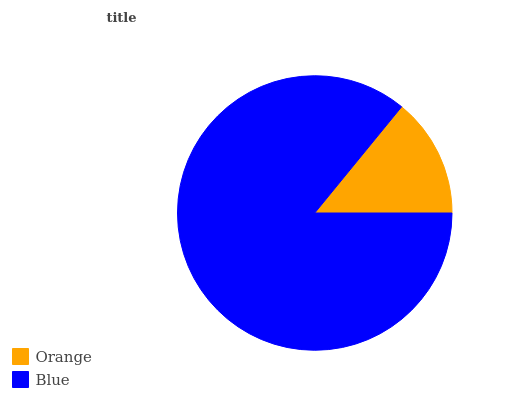Is Orange the minimum?
Answer yes or no. Yes. Is Blue the maximum?
Answer yes or no. Yes. Is Blue the minimum?
Answer yes or no. No. Is Blue greater than Orange?
Answer yes or no. Yes. Is Orange less than Blue?
Answer yes or no. Yes. Is Orange greater than Blue?
Answer yes or no. No. Is Blue less than Orange?
Answer yes or no. No. Is Blue the high median?
Answer yes or no. Yes. Is Orange the low median?
Answer yes or no. Yes. Is Orange the high median?
Answer yes or no. No. Is Blue the low median?
Answer yes or no. No. 